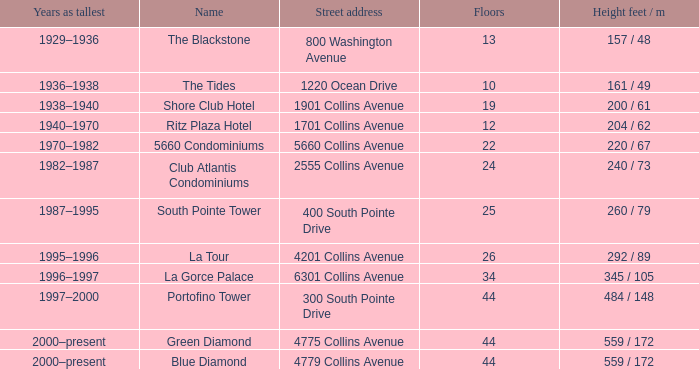What is the height of the Tides with less than 34 floors? 161 / 49. 